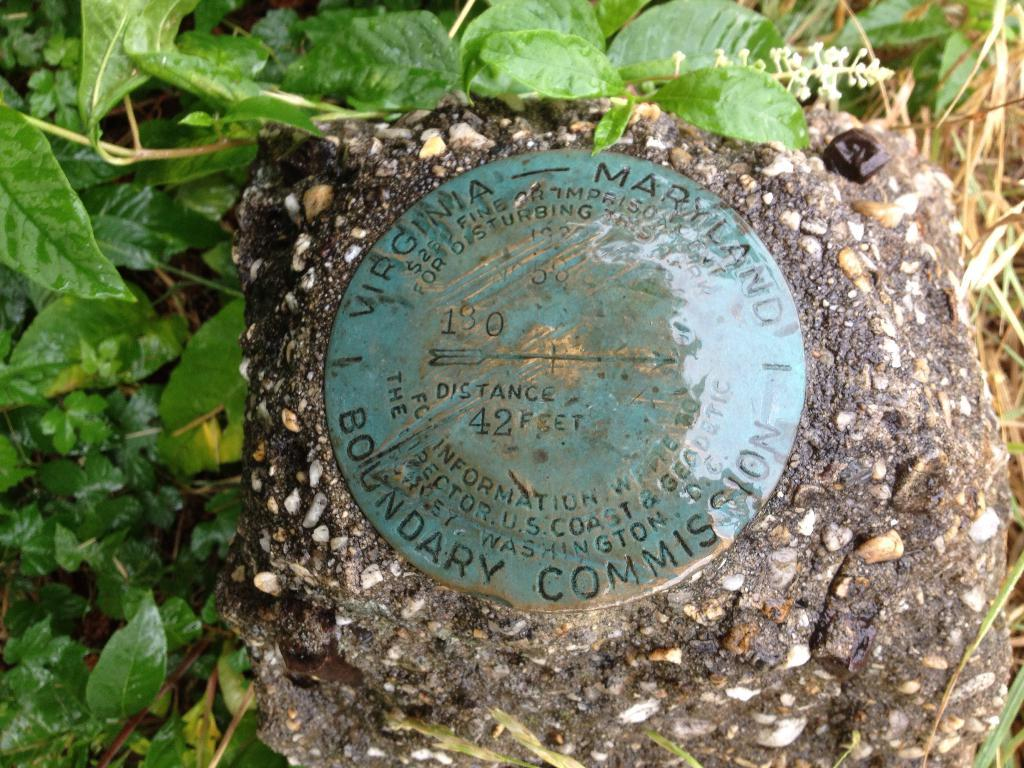What is the object with text and numbers on the ground in the image? The object with text and numbers on the ground is not specified, but it is present in the image. What type of plant is visible in the image? There is a plant with flowers in the image. What can be seen in the background of the image? There are other plants and grass in the background of the image. What type of paste is being used to decorate the stage in the image? There is no stage or paste present in the image; it features an object with text and numbers on the ground, a plant with flowers, and other plants and grass in the background. How many bells are hanging from the plant in the image? There are no bells present on the plant in the image; it has flowers instead. 